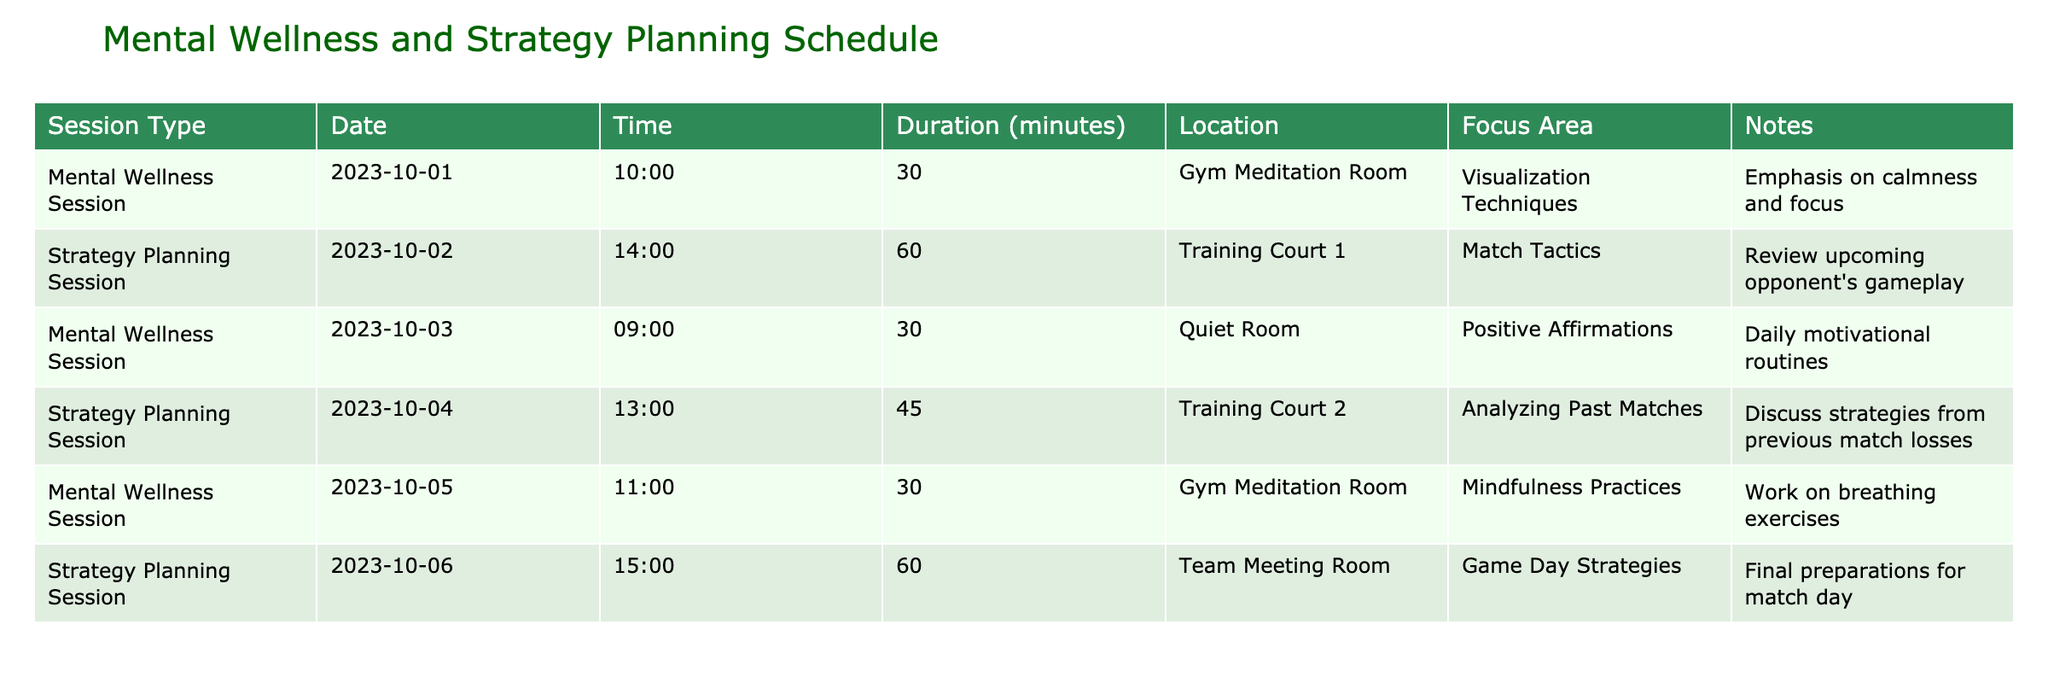What is the duration of the Mental Wellness Session on October 5, 2023? The duration of the Mental Wellness Session on October 5, 2023, is noted in the Duration column for that specific date. It states 30 minutes.
Answer: 30 minutes How many minutes are allocated for the Strategy Planning Session on October 6, 2023? The duration allocated for the Strategy Planning Session on October 6, 2023, can be found in the Duration column corresponding to that date, which is 60 minutes.
Answer: 60 minutes Which session takes place in the Gym Meditation Room, and what is its focus area? In the table, the Mental Wellness Session on October 1, 2023, takes place in the Gym Meditation Room, and its focus area is Visualization Techniques.
Answer: Mental Wellness Session focusing on Visualization Techniques In total, how many Strategy Planning Sessions are scheduled? By counting the rows in the table that correspond to Strategy Planning Sessions, we find that there are 3 such sessions scheduled (on October 2, October 4, and October 6).
Answer: 3 What is the focus area of the first Mental Wellness Session, and how does it differ from the last one? The first Mental Wellness Session focuses on Visualization Techniques held on October 1, 2023, while the last one focuses on Mindfulness Practices held on October 5, 2023. The differences lie in their focus areas on mental strategies.
Answer: Visualization Techniques vs. Mindfulness Practices Is there any session scheduled on October 4, 2023, that focuses on analyzing past matches? Yes, on October 4, 2023, there is a Strategy Planning Session scheduled that focuses on analyzing past matches, as indicated in the table.
Answer: Yes How many total minutes are allocated for all the Mental Wellness Sessions combined? To find the total duration for all Mental Wellness Sessions, sum the durations: 30 + 30 + 30 = 90 minutes. Each of the Mental Wellness Sessions has a duration of 30 minutes.
Answer: 90 minutes Which session has the latest start time, and what is its duration? By examining the Times, the Strategy Planning Session on October 6, 2023, has the latest start time at 15:00 and a duration of 60 minutes.
Answer: Strategy Planning Session at 15:00, duration 60 minutes What are the focus areas of the sessions scheduled on October 2 and October 4, 2023? The focus area for the session on October 2, 2023, is Match Tactics, while the session on October 4 focuses on Analyzing Past Matches.
Answer: Match Tactics and Analyzing Past Matches 